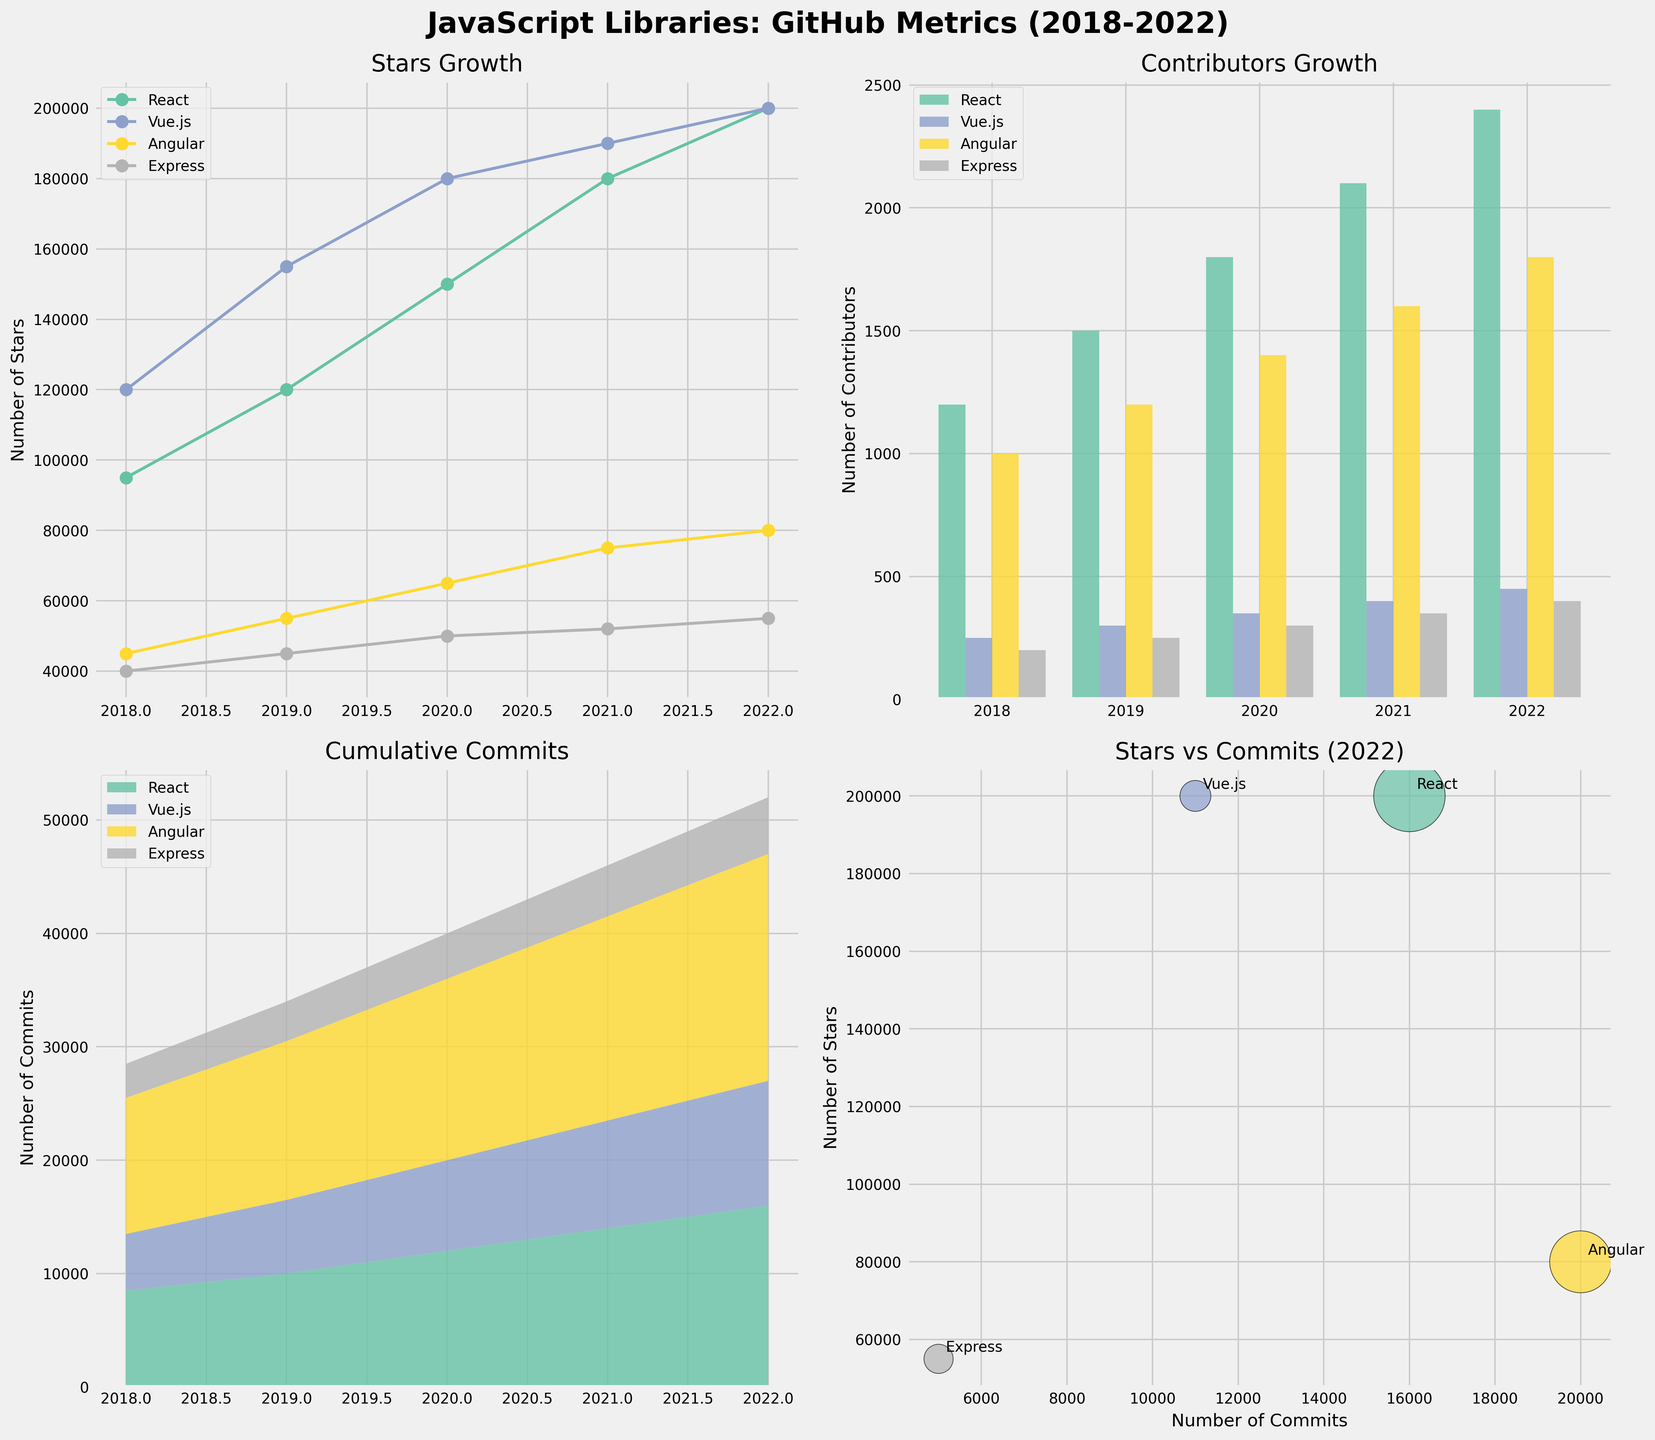what is the title of the figure? The title is located at the top of the figure. It reads "JavaScript Libraries: GitHub Metrics (2018-2022)", which summarizes the overall theme of the figure
Answer: JavaScript Libraries: GitHub Metrics (2018-2022) How many subplots are shown in the figure? The figure is divided into a grid of 2 rows and 2 columns, amounting to 4 subplots in total
Answer: 4 Which library had the highest number of stars in 2022 according to Plot 1? The line chart in Plot 1 shows the number of stars over the years for different libraries. In 2022, React had the highest number of stars
Answer: React What is the trend in the number of contributors for React between 2018 and 2022 according to Plot 2? By observing the bar heights in Plot 2 for React, you can see the number of contributors increases from 1,200 in 2018 to 2,400 in 2022
Answer: Increasing In Plot 3, which library had the most cumulative commits in 2022? The stacked area chart in Plot 3 shows cumulative commits over the years. React sits at the top layer in 2022, indicating it had the most cumulative commits
Answer: React What is the relationship between stars and commits for Vue.js in 2022 according to Plot 4? In Plot 4, each library is plotted as a point representing its stars (y-axis) and commits (x-axis) in 2022. Vue.js has around 200,000 stars and about 11,000 commits
Answer: Around 200,000 stars and 11,000 commits Which library showed the least growth in terms of contributors from 2018 to 2022 according to Plot 2? By comparing the bar heights in Plot 2 for all libraries, Express shows the smallest increase in the number of contributors, from 200 in 2018 to 400 in 2022
Answer: Express By how much did Angular's number of stars increase from 2018 to 2022 according to Plot 1? The stars for Angular rose from 45,000 in 2018 to 80,000 in 2022. The difference is 80,000 - 45,000 = 35,000
Answer: 35,000 What is the average number of commits for React from 2018 to 2022 according to Plot 3? The number of commits for React over these years are 8,500, 10,000, 12,000, 14,000, and 16,000. Summing them gives 60,500. Dividing by the 5 years provides an average of 60,500 / 5 = 12,100
Answer: 12,100 In Plot 4, which library has the fewest stars but the most commits in 2022? The scatter plot in Plot 4 shows each library's position relative to stars and commits. Angular has the fewest stars but the most commits, located at the highest number of commits on the x-axis and a relatively lower number of stars on the y-axis
Answer: Angular 